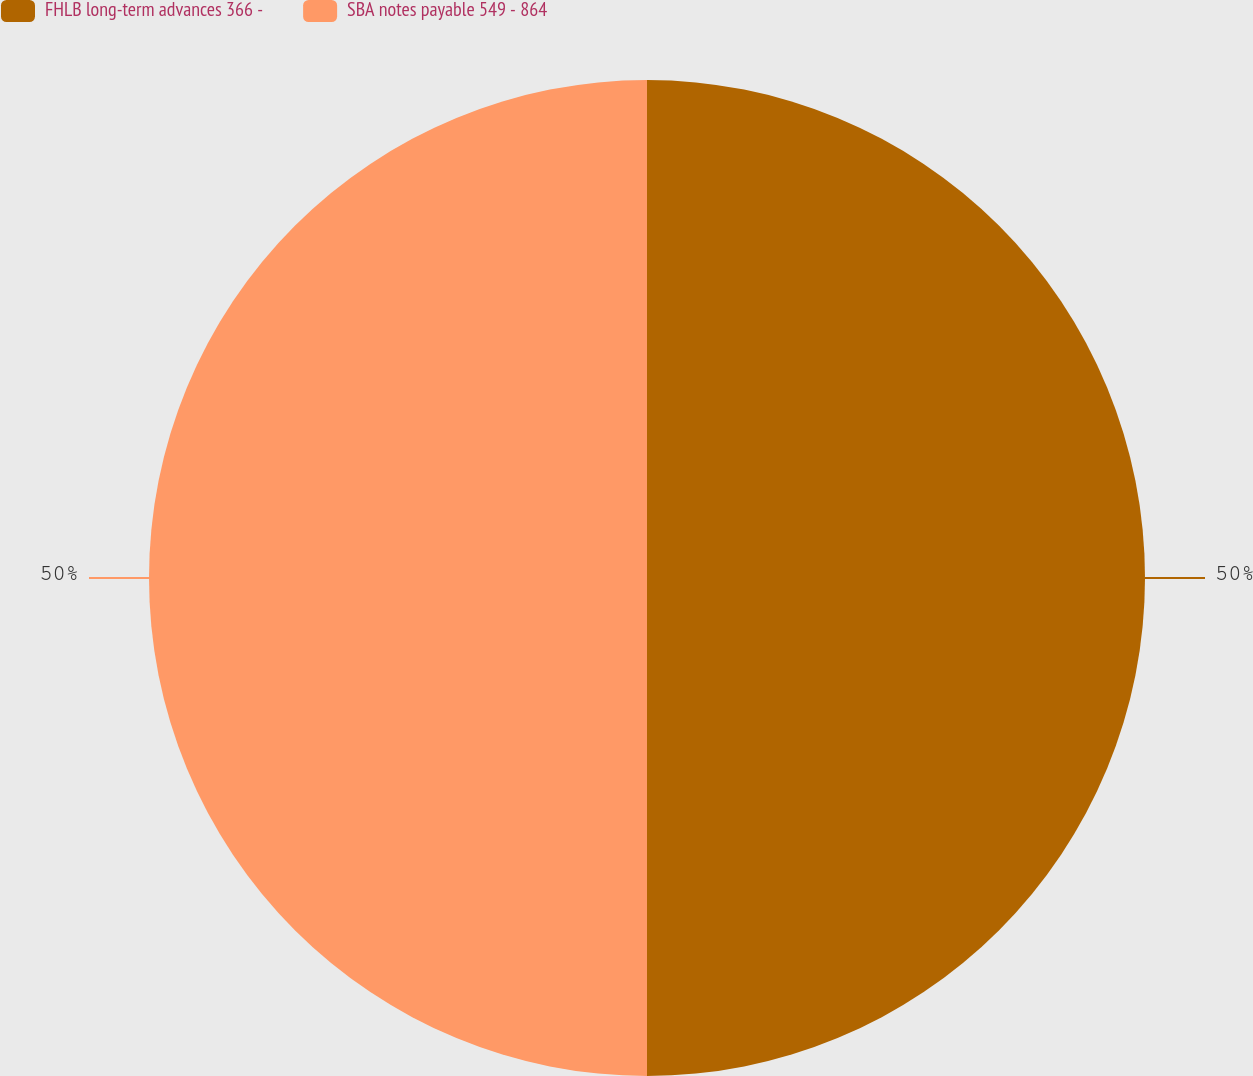Convert chart. <chart><loc_0><loc_0><loc_500><loc_500><pie_chart><fcel>FHLB long-term advances 366 -<fcel>SBA notes payable 549 - 864<nl><fcel>50.0%<fcel>50.0%<nl></chart> 